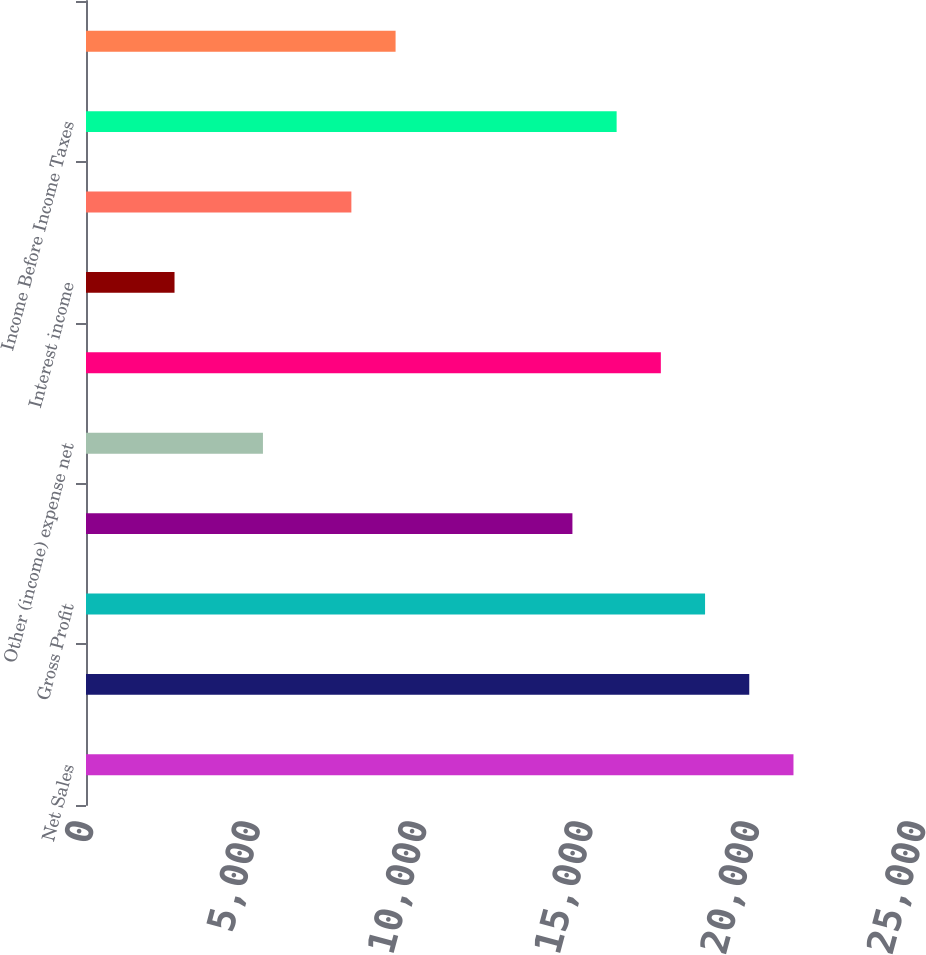<chart> <loc_0><loc_0><loc_500><loc_500><bar_chart><fcel>Net Sales<fcel>Cost of products sold<fcel>Gross Profit<fcel>Marketing research and general<fcel>Other (income) expense net<fcel>Operating Profit<fcel>Interest income<fcel>Interest expense<fcel>Income Before Income Taxes<fcel>Provision for income taxes<nl><fcel>21258.4<fcel>19929.9<fcel>18601.5<fcel>14616.1<fcel>5316.88<fcel>17273<fcel>2659.96<fcel>7973.8<fcel>15944.6<fcel>9302.26<nl></chart> 